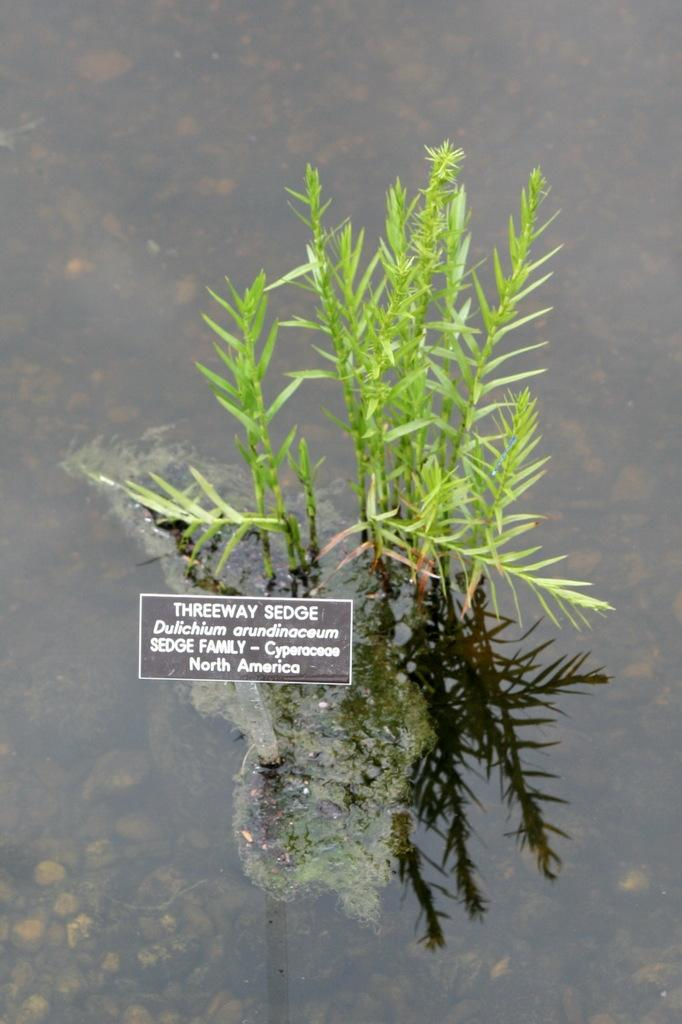What is unusual about the grass in the image? The grass is in the water. What else can be found in the water besides the grass? There are stones in the water. Can you read any text in the image? Yes, there is some text visible in the image. How many legs can be seen supporting the army in the image? There is no army or legs present in the image. What type of care is being provided to the grass in the image? There is no indication of care being provided to the grass in the image. 